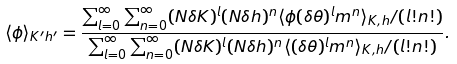Convert formula to latex. <formula><loc_0><loc_0><loc_500><loc_500>\langle \phi \rangle _ { K ^ { \prime } h ^ { \prime } } = \frac { \sum _ { l = 0 } ^ { \infty } \sum _ { n = 0 } ^ { \infty } ( N \delta K ) ^ { l } ( N \delta h ) ^ { n } \langle \phi ( \delta \theta ) ^ { l } m ^ { n } \rangle _ { K , h } / ( l ! n ! ) } { \sum _ { l = 0 } ^ { \infty } \sum _ { n = 0 } ^ { \infty } ( N \delta K ) ^ { l } ( N \delta h ) ^ { n } \langle ( \delta \theta ) ^ { l } m ^ { n } \rangle _ { K , h } / ( l ! n ! ) } .</formula> 